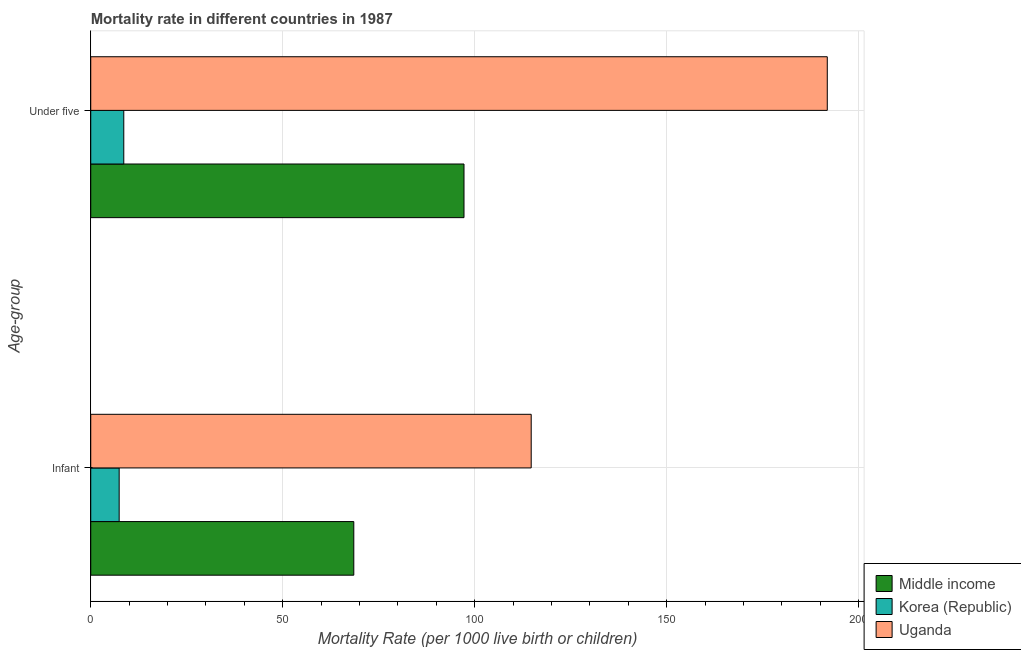Are the number of bars per tick equal to the number of legend labels?
Provide a short and direct response. Yes. Are the number of bars on each tick of the Y-axis equal?
Provide a succinct answer. Yes. How many bars are there on the 2nd tick from the top?
Keep it short and to the point. 3. How many bars are there on the 2nd tick from the bottom?
Provide a succinct answer. 3. What is the label of the 2nd group of bars from the top?
Ensure brevity in your answer.  Infant. What is the under-5 mortality rate in Middle income?
Your response must be concise. 97.2. Across all countries, what is the maximum infant mortality rate?
Your answer should be very brief. 114.7. In which country was the under-5 mortality rate maximum?
Your answer should be very brief. Uganda. What is the total infant mortality rate in the graph?
Your response must be concise. 190.6. What is the difference between the under-5 mortality rate in Uganda and that in Middle income?
Provide a short and direct response. 94.6. What is the difference between the infant mortality rate in Middle income and the under-5 mortality rate in Uganda?
Your answer should be very brief. -123.3. What is the average infant mortality rate per country?
Your answer should be very brief. 63.53. What is the difference between the under-5 mortality rate and infant mortality rate in Uganda?
Provide a succinct answer. 77.1. What is the ratio of the infant mortality rate in Uganda to that in Korea (Republic)?
Provide a short and direct response. 15.5. What does the 3rd bar from the bottom in Under five represents?
Ensure brevity in your answer.  Uganda. How many bars are there?
Offer a very short reply. 6. Does the graph contain any zero values?
Make the answer very short. No. How many legend labels are there?
Keep it short and to the point. 3. How are the legend labels stacked?
Offer a terse response. Vertical. What is the title of the graph?
Keep it short and to the point. Mortality rate in different countries in 1987. What is the label or title of the X-axis?
Provide a succinct answer. Mortality Rate (per 1000 live birth or children). What is the label or title of the Y-axis?
Provide a succinct answer. Age-group. What is the Mortality Rate (per 1000 live birth or children) in Middle income in Infant?
Keep it short and to the point. 68.5. What is the Mortality Rate (per 1000 live birth or children) of Korea (Republic) in Infant?
Provide a succinct answer. 7.4. What is the Mortality Rate (per 1000 live birth or children) in Uganda in Infant?
Provide a succinct answer. 114.7. What is the Mortality Rate (per 1000 live birth or children) in Middle income in Under five?
Provide a short and direct response. 97.2. What is the Mortality Rate (per 1000 live birth or children) in Uganda in Under five?
Give a very brief answer. 191.8. Across all Age-group, what is the maximum Mortality Rate (per 1000 live birth or children) in Middle income?
Ensure brevity in your answer.  97.2. Across all Age-group, what is the maximum Mortality Rate (per 1000 live birth or children) in Korea (Republic)?
Ensure brevity in your answer.  8.6. Across all Age-group, what is the maximum Mortality Rate (per 1000 live birth or children) of Uganda?
Keep it short and to the point. 191.8. Across all Age-group, what is the minimum Mortality Rate (per 1000 live birth or children) of Middle income?
Give a very brief answer. 68.5. Across all Age-group, what is the minimum Mortality Rate (per 1000 live birth or children) in Korea (Republic)?
Your answer should be compact. 7.4. Across all Age-group, what is the minimum Mortality Rate (per 1000 live birth or children) of Uganda?
Offer a terse response. 114.7. What is the total Mortality Rate (per 1000 live birth or children) in Middle income in the graph?
Your answer should be very brief. 165.7. What is the total Mortality Rate (per 1000 live birth or children) in Korea (Republic) in the graph?
Make the answer very short. 16. What is the total Mortality Rate (per 1000 live birth or children) in Uganda in the graph?
Ensure brevity in your answer.  306.5. What is the difference between the Mortality Rate (per 1000 live birth or children) of Middle income in Infant and that in Under five?
Give a very brief answer. -28.7. What is the difference between the Mortality Rate (per 1000 live birth or children) in Uganda in Infant and that in Under five?
Your answer should be compact. -77.1. What is the difference between the Mortality Rate (per 1000 live birth or children) of Middle income in Infant and the Mortality Rate (per 1000 live birth or children) of Korea (Republic) in Under five?
Give a very brief answer. 59.9. What is the difference between the Mortality Rate (per 1000 live birth or children) in Middle income in Infant and the Mortality Rate (per 1000 live birth or children) in Uganda in Under five?
Offer a terse response. -123.3. What is the difference between the Mortality Rate (per 1000 live birth or children) of Korea (Republic) in Infant and the Mortality Rate (per 1000 live birth or children) of Uganda in Under five?
Provide a short and direct response. -184.4. What is the average Mortality Rate (per 1000 live birth or children) in Middle income per Age-group?
Provide a short and direct response. 82.85. What is the average Mortality Rate (per 1000 live birth or children) of Uganda per Age-group?
Offer a very short reply. 153.25. What is the difference between the Mortality Rate (per 1000 live birth or children) of Middle income and Mortality Rate (per 1000 live birth or children) of Korea (Republic) in Infant?
Offer a very short reply. 61.1. What is the difference between the Mortality Rate (per 1000 live birth or children) of Middle income and Mortality Rate (per 1000 live birth or children) of Uganda in Infant?
Give a very brief answer. -46.2. What is the difference between the Mortality Rate (per 1000 live birth or children) in Korea (Republic) and Mortality Rate (per 1000 live birth or children) in Uganda in Infant?
Keep it short and to the point. -107.3. What is the difference between the Mortality Rate (per 1000 live birth or children) of Middle income and Mortality Rate (per 1000 live birth or children) of Korea (Republic) in Under five?
Your answer should be compact. 88.6. What is the difference between the Mortality Rate (per 1000 live birth or children) of Middle income and Mortality Rate (per 1000 live birth or children) of Uganda in Under five?
Offer a very short reply. -94.6. What is the difference between the Mortality Rate (per 1000 live birth or children) in Korea (Republic) and Mortality Rate (per 1000 live birth or children) in Uganda in Under five?
Provide a succinct answer. -183.2. What is the ratio of the Mortality Rate (per 1000 live birth or children) in Middle income in Infant to that in Under five?
Your answer should be compact. 0.7. What is the ratio of the Mortality Rate (per 1000 live birth or children) of Korea (Republic) in Infant to that in Under five?
Your answer should be very brief. 0.86. What is the ratio of the Mortality Rate (per 1000 live birth or children) in Uganda in Infant to that in Under five?
Your answer should be very brief. 0.6. What is the difference between the highest and the second highest Mortality Rate (per 1000 live birth or children) in Middle income?
Make the answer very short. 28.7. What is the difference between the highest and the second highest Mortality Rate (per 1000 live birth or children) of Uganda?
Provide a short and direct response. 77.1. What is the difference between the highest and the lowest Mortality Rate (per 1000 live birth or children) in Middle income?
Your answer should be very brief. 28.7. What is the difference between the highest and the lowest Mortality Rate (per 1000 live birth or children) in Uganda?
Your answer should be very brief. 77.1. 